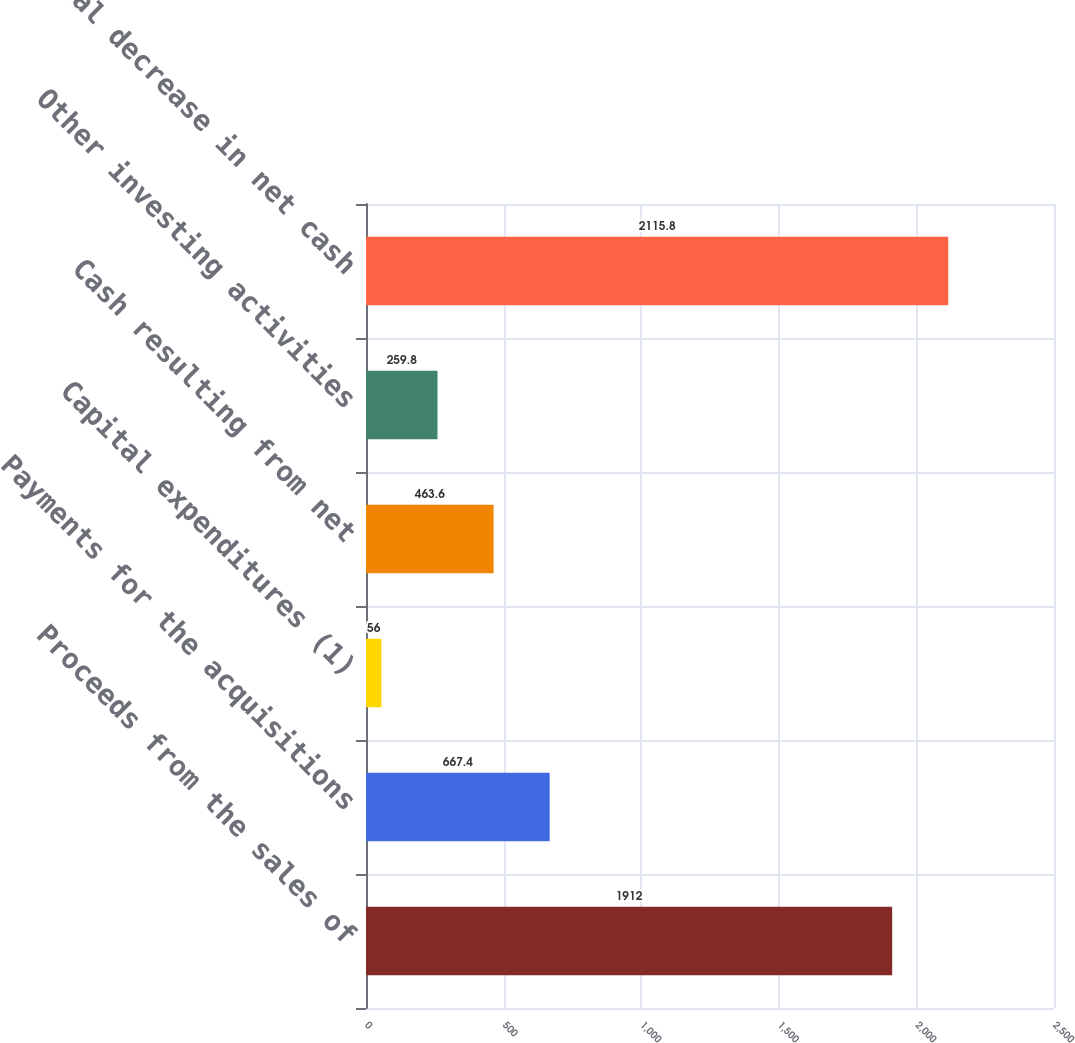Convert chart. <chart><loc_0><loc_0><loc_500><loc_500><bar_chart><fcel>Proceeds from the sales of<fcel>Payments for the acquisitions<fcel>Capital expenditures (1)<fcel>Cash resulting from net<fcel>Other investing activities<fcel>Total decrease in net cash<nl><fcel>1912<fcel>667.4<fcel>56<fcel>463.6<fcel>259.8<fcel>2115.8<nl></chart> 